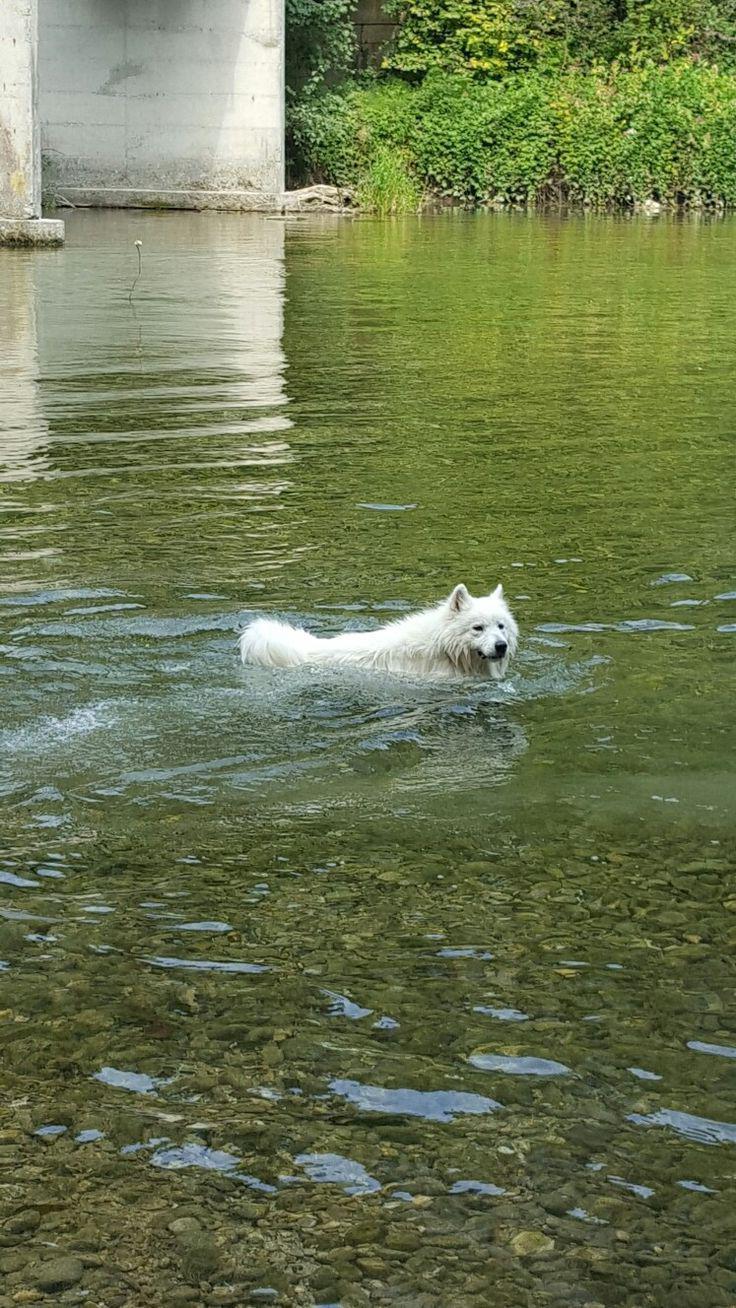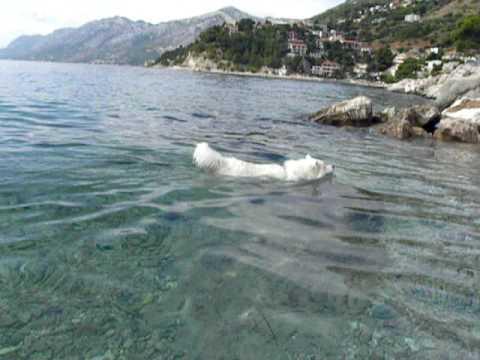The first image is the image on the left, the second image is the image on the right. For the images displayed, is the sentence "Both dogs are swimming in the water." factually correct? Answer yes or no. Yes. The first image is the image on the left, the second image is the image on the right. For the images displayed, is the sentence "There is a dog swimming to the right in both images." factually correct? Answer yes or no. Yes. 